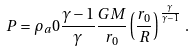<formula> <loc_0><loc_0><loc_500><loc_500>P = \rho _ { a } 0 \frac { \gamma - 1 } { \gamma } \frac { G M } { r _ { 0 } } \left ( \frac { r _ { 0 } } { R } \right ) ^ { \frac { \gamma } { \gamma - 1 } } \, .</formula> 